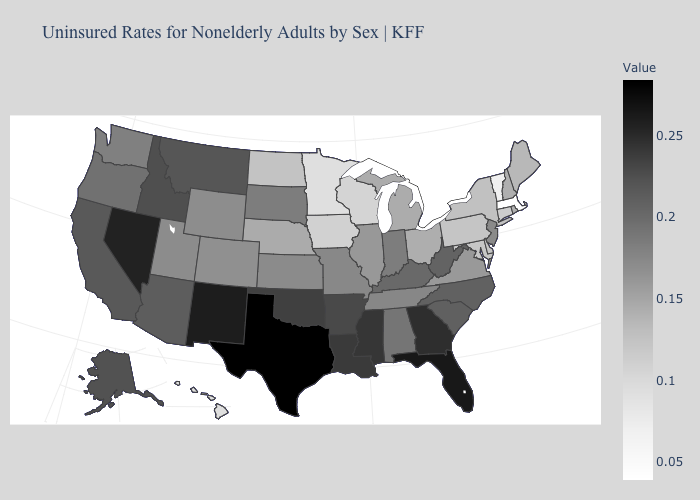Among the states that border North Dakota , which have the lowest value?
Short answer required. Minnesota. Among the states that border Michigan , which have the lowest value?
Write a very short answer. Wisconsin. Which states have the lowest value in the South?
Be succinct. Maryland. Which states have the lowest value in the USA?
Quick response, please. Massachusetts. Which states have the lowest value in the South?
Keep it brief. Maryland. Among the states that border Connecticut , which have the highest value?
Quick response, please. Rhode Island. Among the states that border Oklahoma , does Missouri have the highest value?
Short answer required. No. Does Texas have the highest value in the USA?
Concise answer only. Yes. Does Wisconsin have a lower value than Vermont?
Write a very short answer. No. Which states have the lowest value in the South?
Write a very short answer. Maryland. 